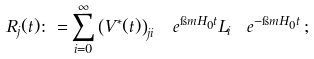Convert formula to latex. <formula><loc_0><loc_0><loc_500><loc_500>R _ { j } ( t ) \colon = \sum _ { i = 0 } ^ { \infty } \left ( V ^ { * } ( t ) \right ) _ { j i } \, \ e ^ { \i m H _ { 0 } t } L _ { i } \, \ e ^ { - \i m H _ { 0 } t } \, ;</formula> 